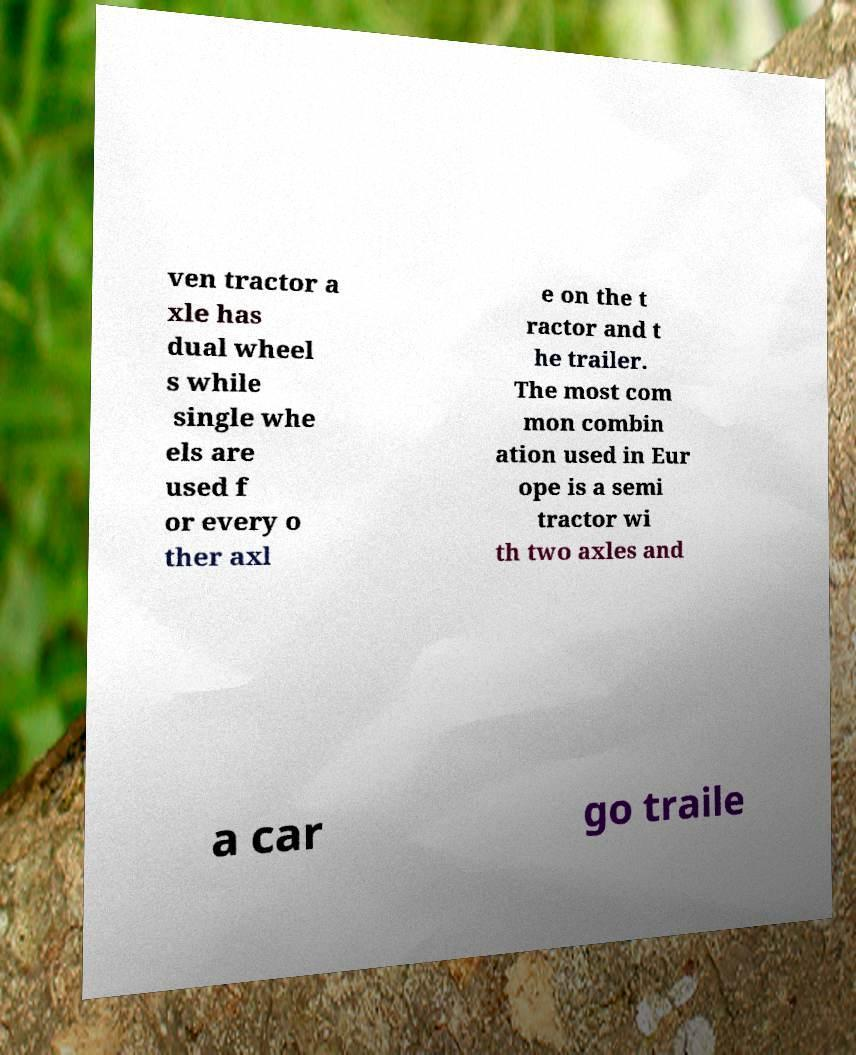Can you accurately transcribe the text from the provided image for me? ven tractor a xle has dual wheel s while single whe els are used f or every o ther axl e on the t ractor and t he trailer. The most com mon combin ation used in Eur ope is a semi tractor wi th two axles and a car go traile 